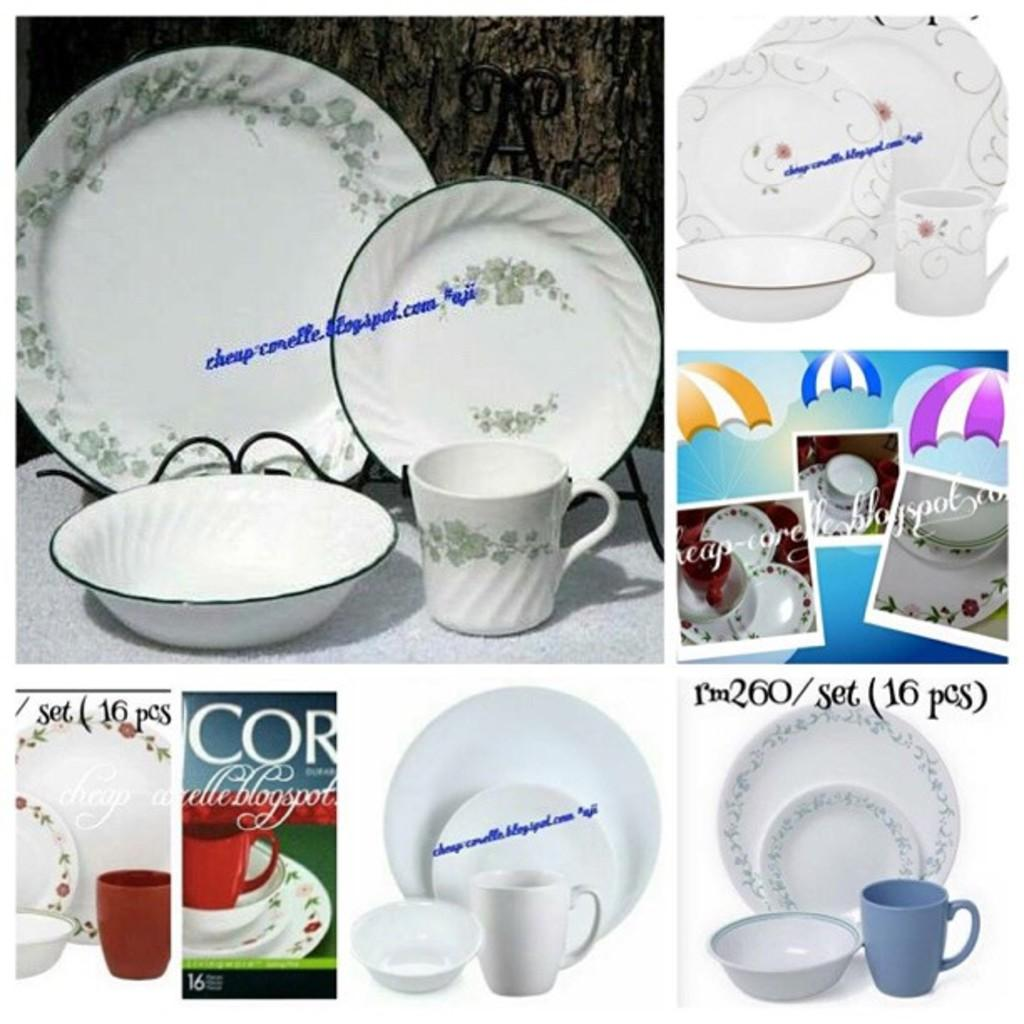What type of visual arrangement is present in the image? The image contains a collage of pictures. What objects can be seen in the pictures within the collage? The pictures include plates, mugs, and bowls. Is there any text present in the collage of pictures? Yes, there is some text visible in the collage of pictures. What type of notebook is being used to create friction in the image? There is no notebook or friction present in the image; it features a collage of pictures with plates, mugs, bowls, and text. 